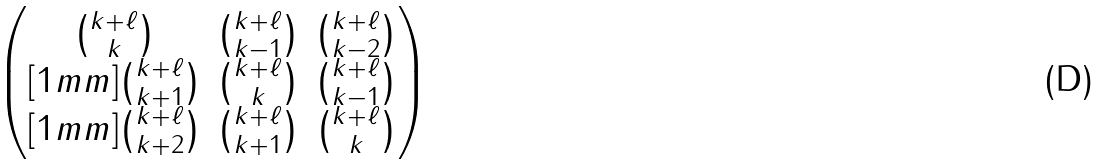<formula> <loc_0><loc_0><loc_500><loc_500>\begin{pmatrix} { k + \ell \choose k } & { k + \ell \choose k - 1 } & { k + \ell \choose k - 2 } \\ [ 1 m m ] { k + \ell \choose k + 1 } & { k + \ell \choose k } & { k + \ell \choose k - 1 } \\ [ 1 m m ] { k + \ell \choose k + 2 } & { k + \ell \choose k + 1 } & { k + \ell \choose k } \end{pmatrix}</formula> 